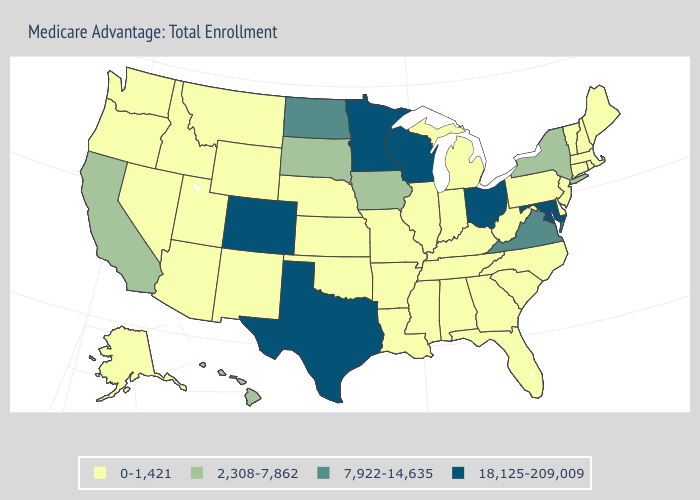Name the states that have a value in the range 2,308-7,862?
Short answer required. California, Hawaii, Iowa, New York, South Dakota. Name the states that have a value in the range 0-1,421?
Give a very brief answer. Alaska, Alabama, Arkansas, Arizona, Connecticut, Delaware, Florida, Georgia, Idaho, Illinois, Indiana, Kansas, Kentucky, Louisiana, Massachusetts, Maine, Michigan, Missouri, Mississippi, Montana, North Carolina, Nebraska, New Hampshire, New Jersey, New Mexico, Nevada, Oklahoma, Oregon, Pennsylvania, Rhode Island, South Carolina, Tennessee, Utah, Vermont, Washington, West Virginia, Wyoming. Does California have the lowest value in the West?
Concise answer only. No. Name the states that have a value in the range 18,125-209,009?
Give a very brief answer. Colorado, Maryland, Minnesota, Ohio, Texas, Wisconsin. Name the states that have a value in the range 7,922-14,635?
Be succinct. North Dakota, Virginia. What is the value of Vermont?
Answer briefly. 0-1,421. Which states have the lowest value in the South?
Be succinct. Alabama, Arkansas, Delaware, Florida, Georgia, Kentucky, Louisiana, Mississippi, North Carolina, Oklahoma, South Carolina, Tennessee, West Virginia. What is the value of Utah?
Give a very brief answer. 0-1,421. Which states hav the highest value in the MidWest?
Keep it brief. Minnesota, Ohio, Wisconsin. What is the value of Wyoming?
Short answer required. 0-1,421. What is the value of Kansas?
Quick response, please. 0-1,421. Among the states that border Wyoming , does Colorado have the highest value?
Write a very short answer. Yes. Among the states that border Colorado , which have the highest value?
Write a very short answer. Arizona, Kansas, Nebraska, New Mexico, Oklahoma, Utah, Wyoming. Does Alabama have the lowest value in the USA?
Give a very brief answer. Yes. Name the states that have a value in the range 7,922-14,635?
Write a very short answer. North Dakota, Virginia. 